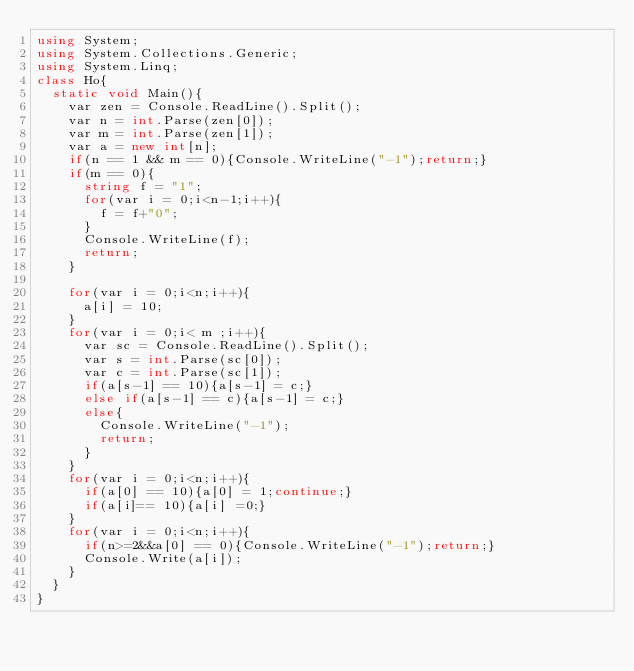Convert code to text. <code><loc_0><loc_0><loc_500><loc_500><_C#_>using System;
using System.Collections.Generic;
using System.Linq;
class Ho{
  static void Main(){
    var zen = Console.ReadLine().Split();
    var n = int.Parse(zen[0]);
    var m = int.Parse(zen[1]);
    var a = new int[n];
    if(n == 1 && m == 0){Console.WriteLine("-1");return;}
    if(m == 0){
      string f = "1";
      for(var i = 0;i<n-1;i++){
        f = f+"0";
      }
      Console.WriteLine(f);
      return;
    }
    
    for(var i = 0;i<n;i++){
      a[i] = 10;
    }
    for(var i = 0;i< m ;i++){
      var sc = Console.ReadLine().Split();
      var s = int.Parse(sc[0]);
      var c = int.Parse(sc[1]);
      if(a[s-1] == 10){a[s-1] = c;}
      else if(a[s-1] == c){a[s-1] = c;}
      else{
        Console.WriteLine("-1");
        return;
      }  
    }
    for(var i = 0;i<n;i++){
      if(a[0] == 10){a[0] = 1;continue;}
      if(a[i]== 10){a[i] =0;}
    }
    for(var i = 0;i<n;i++){
      if(n>=2&&a[0] == 0){Console.WriteLine("-1");return;}
      Console.Write(a[i]);
    }
  }
}</code> 